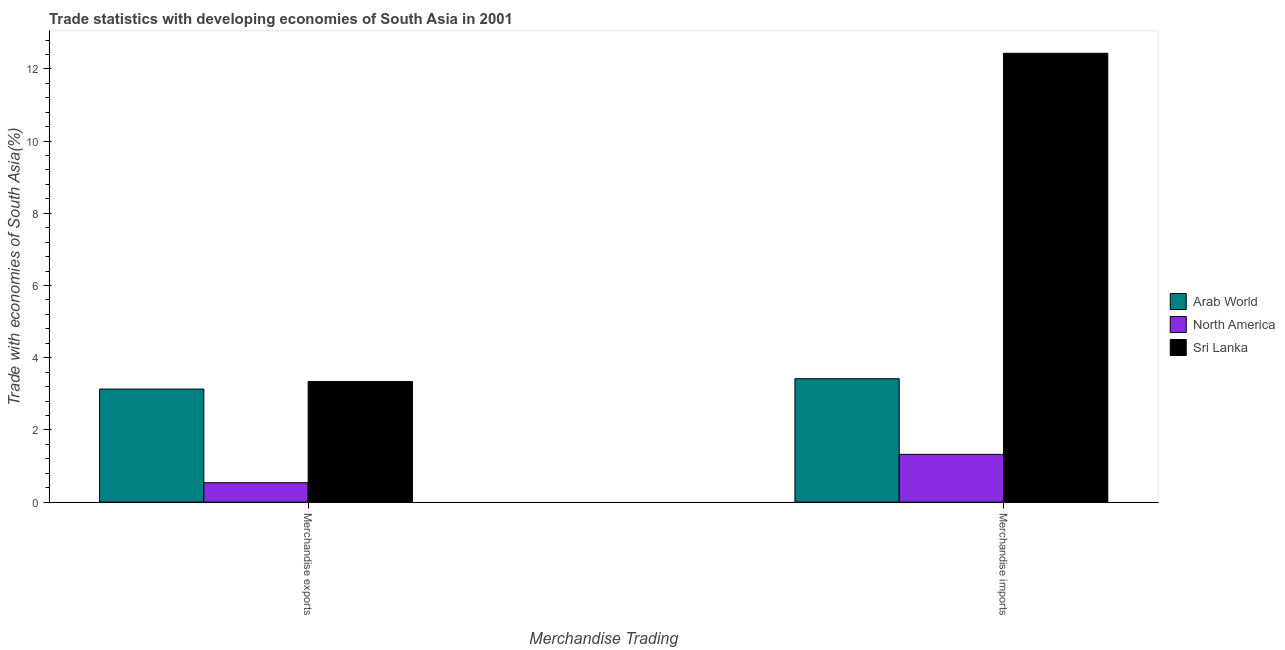Are the number of bars on each tick of the X-axis equal?
Provide a succinct answer. Yes. How many bars are there on the 1st tick from the right?
Provide a short and direct response. 3. What is the label of the 2nd group of bars from the left?
Your response must be concise. Merchandise imports. What is the merchandise exports in Sri Lanka?
Your answer should be compact. 3.34. Across all countries, what is the maximum merchandise exports?
Provide a succinct answer. 3.34. Across all countries, what is the minimum merchandise exports?
Keep it short and to the point. 0.54. In which country was the merchandise exports maximum?
Provide a short and direct response. Sri Lanka. In which country was the merchandise imports minimum?
Give a very brief answer. North America. What is the total merchandise exports in the graph?
Offer a very short reply. 7.01. What is the difference between the merchandise imports in North America and that in Arab World?
Your response must be concise. -2.1. What is the difference between the merchandise imports in North America and the merchandise exports in Sri Lanka?
Provide a short and direct response. -2.02. What is the average merchandise imports per country?
Offer a very short reply. 5.72. What is the difference between the merchandise imports and merchandise exports in Sri Lanka?
Make the answer very short. 9.09. What is the ratio of the merchandise imports in Arab World to that in Sri Lanka?
Your response must be concise. 0.27. Is the merchandise imports in North America less than that in Sri Lanka?
Your answer should be compact. Yes. What does the 3rd bar from the left in Merchandise imports represents?
Your answer should be very brief. Sri Lanka. What does the 3rd bar from the right in Merchandise imports represents?
Ensure brevity in your answer.  Arab World. How many bars are there?
Give a very brief answer. 6. Are all the bars in the graph horizontal?
Offer a terse response. No. Are the values on the major ticks of Y-axis written in scientific E-notation?
Offer a very short reply. No. Does the graph contain any zero values?
Provide a succinct answer. No. Does the graph contain grids?
Offer a terse response. No. Where does the legend appear in the graph?
Your answer should be very brief. Center right. What is the title of the graph?
Offer a terse response. Trade statistics with developing economies of South Asia in 2001. Does "Korea (Republic)" appear as one of the legend labels in the graph?
Give a very brief answer. No. What is the label or title of the X-axis?
Your response must be concise. Merchandise Trading. What is the label or title of the Y-axis?
Make the answer very short. Trade with economies of South Asia(%). What is the Trade with economies of South Asia(%) of Arab World in Merchandise exports?
Give a very brief answer. 3.13. What is the Trade with economies of South Asia(%) in North America in Merchandise exports?
Keep it short and to the point. 0.54. What is the Trade with economies of South Asia(%) in Sri Lanka in Merchandise exports?
Provide a short and direct response. 3.34. What is the Trade with economies of South Asia(%) of Arab World in Merchandise imports?
Your answer should be very brief. 3.42. What is the Trade with economies of South Asia(%) in North America in Merchandise imports?
Your answer should be very brief. 1.32. What is the Trade with economies of South Asia(%) in Sri Lanka in Merchandise imports?
Provide a succinct answer. 12.43. Across all Merchandise Trading, what is the maximum Trade with economies of South Asia(%) in Arab World?
Give a very brief answer. 3.42. Across all Merchandise Trading, what is the maximum Trade with economies of South Asia(%) of North America?
Offer a very short reply. 1.32. Across all Merchandise Trading, what is the maximum Trade with economies of South Asia(%) of Sri Lanka?
Make the answer very short. 12.43. Across all Merchandise Trading, what is the minimum Trade with economies of South Asia(%) in Arab World?
Offer a terse response. 3.13. Across all Merchandise Trading, what is the minimum Trade with economies of South Asia(%) of North America?
Ensure brevity in your answer.  0.54. Across all Merchandise Trading, what is the minimum Trade with economies of South Asia(%) in Sri Lanka?
Ensure brevity in your answer.  3.34. What is the total Trade with economies of South Asia(%) in Arab World in the graph?
Provide a short and direct response. 6.55. What is the total Trade with economies of South Asia(%) in North America in the graph?
Ensure brevity in your answer.  1.86. What is the total Trade with economies of South Asia(%) in Sri Lanka in the graph?
Keep it short and to the point. 15.77. What is the difference between the Trade with economies of South Asia(%) in Arab World in Merchandise exports and that in Merchandise imports?
Provide a short and direct response. -0.29. What is the difference between the Trade with economies of South Asia(%) in North America in Merchandise exports and that in Merchandise imports?
Your answer should be very brief. -0.79. What is the difference between the Trade with economies of South Asia(%) of Sri Lanka in Merchandise exports and that in Merchandise imports?
Provide a short and direct response. -9.09. What is the difference between the Trade with economies of South Asia(%) in Arab World in Merchandise exports and the Trade with economies of South Asia(%) in North America in Merchandise imports?
Your answer should be compact. 1.81. What is the difference between the Trade with economies of South Asia(%) of Arab World in Merchandise exports and the Trade with economies of South Asia(%) of Sri Lanka in Merchandise imports?
Offer a very short reply. -9.3. What is the difference between the Trade with economies of South Asia(%) of North America in Merchandise exports and the Trade with economies of South Asia(%) of Sri Lanka in Merchandise imports?
Give a very brief answer. -11.9. What is the average Trade with economies of South Asia(%) in Arab World per Merchandise Trading?
Make the answer very short. 3.27. What is the average Trade with economies of South Asia(%) in North America per Merchandise Trading?
Offer a terse response. 0.93. What is the average Trade with economies of South Asia(%) of Sri Lanka per Merchandise Trading?
Ensure brevity in your answer.  7.89. What is the difference between the Trade with economies of South Asia(%) in Arab World and Trade with economies of South Asia(%) in North America in Merchandise exports?
Your response must be concise. 2.59. What is the difference between the Trade with economies of South Asia(%) in Arab World and Trade with economies of South Asia(%) in Sri Lanka in Merchandise exports?
Provide a short and direct response. -0.21. What is the difference between the Trade with economies of South Asia(%) in North America and Trade with economies of South Asia(%) in Sri Lanka in Merchandise exports?
Provide a short and direct response. -2.8. What is the difference between the Trade with economies of South Asia(%) of Arab World and Trade with economies of South Asia(%) of North America in Merchandise imports?
Provide a succinct answer. 2.1. What is the difference between the Trade with economies of South Asia(%) in Arab World and Trade with economies of South Asia(%) in Sri Lanka in Merchandise imports?
Keep it short and to the point. -9.01. What is the difference between the Trade with economies of South Asia(%) of North America and Trade with economies of South Asia(%) of Sri Lanka in Merchandise imports?
Provide a short and direct response. -11.11. What is the ratio of the Trade with economies of South Asia(%) in Arab World in Merchandise exports to that in Merchandise imports?
Your response must be concise. 0.92. What is the ratio of the Trade with economies of South Asia(%) in North America in Merchandise exports to that in Merchandise imports?
Offer a terse response. 0.41. What is the ratio of the Trade with economies of South Asia(%) in Sri Lanka in Merchandise exports to that in Merchandise imports?
Ensure brevity in your answer.  0.27. What is the difference between the highest and the second highest Trade with economies of South Asia(%) in Arab World?
Ensure brevity in your answer.  0.29. What is the difference between the highest and the second highest Trade with economies of South Asia(%) in North America?
Give a very brief answer. 0.79. What is the difference between the highest and the second highest Trade with economies of South Asia(%) of Sri Lanka?
Offer a very short reply. 9.09. What is the difference between the highest and the lowest Trade with economies of South Asia(%) in Arab World?
Keep it short and to the point. 0.29. What is the difference between the highest and the lowest Trade with economies of South Asia(%) in North America?
Your response must be concise. 0.79. What is the difference between the highest and the lowest Trade with economies of South Asia(%) of Sri Lanka?
Offer a terse response. 9.09. 